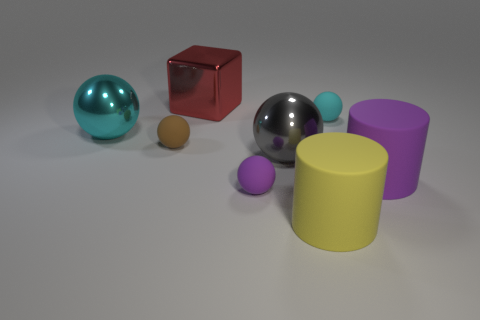Subtract all purple rubber spheres. How many spheres are left? 4 Subtract 2 balls. How many balls are left? 3 Subtract all purple balls. How many balls are left? 4 Add 1 small blue objects. How many objects exist? 9 Subtract all brown spheres. Subtract all red blocks. How many spheres are left? 4 Subtract all balls. How many objects are left? 3 Add 3 tiny spheres. How many tiny spheres are left? 6 Add 3 large gray shiny things. How many large gray shiny things exist? 4 Subtract 1 yellow cylinders. How many objects are left? 7 Subtract all tiny cubes. Subtract all big gray things. How many objects are left? 7 